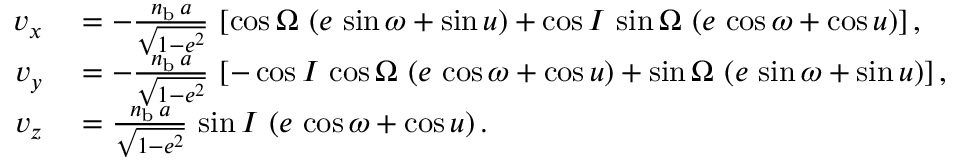Convert formula to latex. <formula><loc_0><loc_0><loc_500><loc_500>\begin{array} { r l } { v _ { x } } & = - \frac { n _ { b } \, a } { \sqrt { 1 - e ^ { 2 } } } \, \left [ \cos \Omega \, \left ( e \, \sin \omega + \sin u \right ) + \cos I \, \sin \Omega \, \left ( e \, \cos \omega + \cos u \right ) \right ] , } \\ { v _ { y } } & = - \frac { n _ { b } \, a } { \sqrt { 1 - e ^ { 2 } } } \, \left [ - \cos I \, \cos \Omega \, \left ( e \, \cos \omega + \cos u \right ) + \sin \Omega \, \left ( e \, \sin \omega + \sin u \right ) \right ] , } \\ { v _ { z } } & = \frac { n _ { b } \, a } { \sqrt { 1 - e ^ { 2 } } } \, \sin I \, \left ( e \, \cos \omega + \cos u \right ) . } \end{array}</formula> 